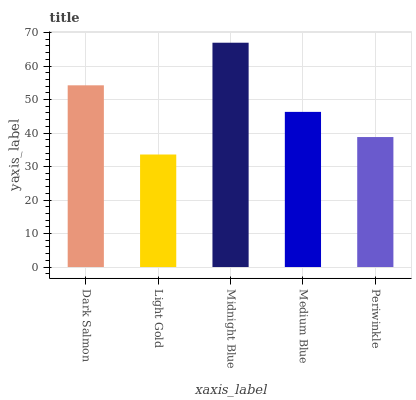Is Midnight Blue the minimum?
Answer yes or no. No. Is Light Gold the maximum?
Answer yes or no. No. Is Midnight Blue greater than Light Gold?
Answer yes or no. Yes. Is Light Gold less than Midnight Blue?
Answer yes or no. Yes. Is Light Gold greater than Midnight Blue?
Answer yes or no. No. Is Midnight Blue less than Light Gold?
Answer yes or no. No. Is Medium Blue the high median?
Answer yes or no. Yes. Is Medium Blue the low median?
Answer yes or no. Yes. Is Periwinkle the high median?
Answer yes or no. No. Is Periwinkle the low median?
Answer yes or no. No. 